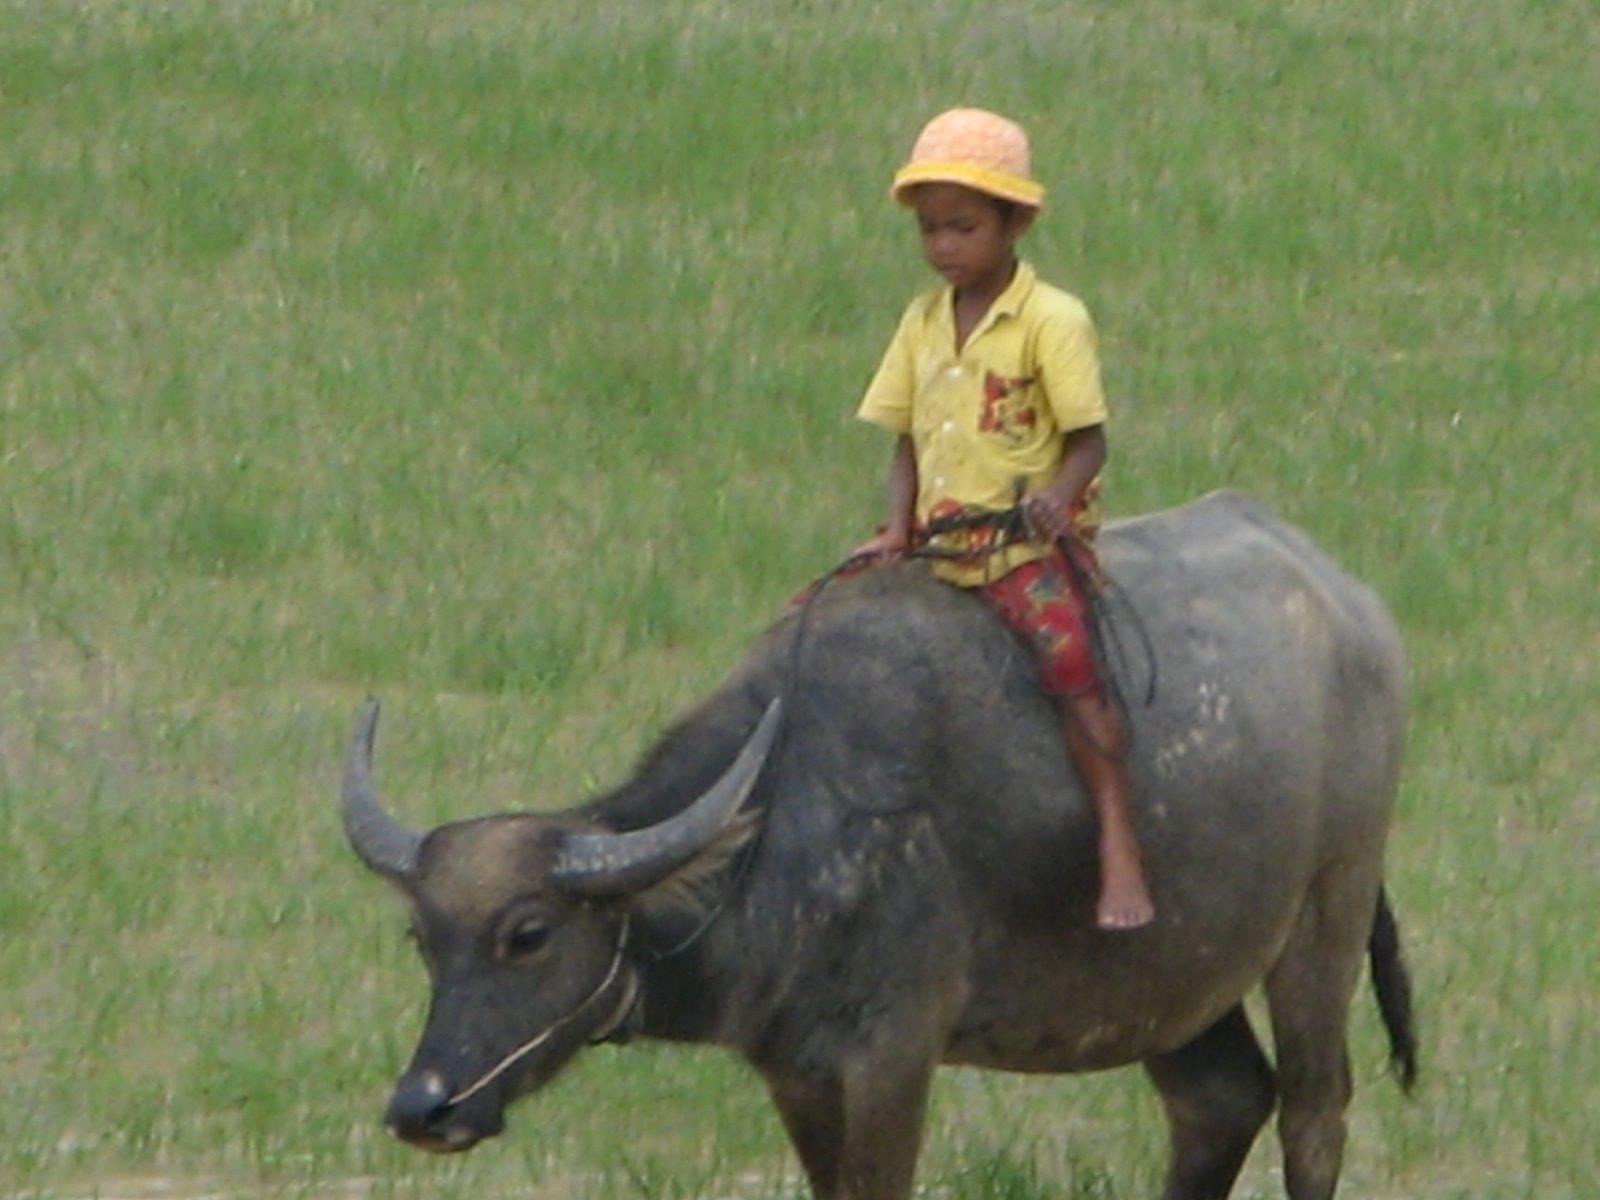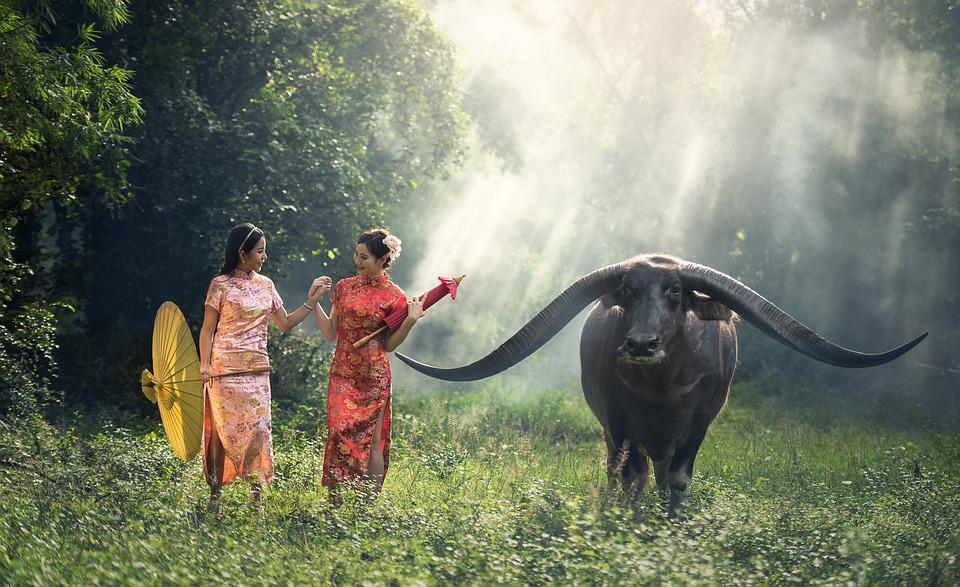The first image is the image on the left, the second image is the image on the right. For the images displayed, is the sentence "There is at least one person in each image with a water buffalo." factually correct? Answer yes or no. Yes. The first image is the image on the left, the second image is the image on the right. Considering the images on both sides, is "Only one of the images contains a sole rider on a water buffalo." valid? Answer yes or no. Yes. 